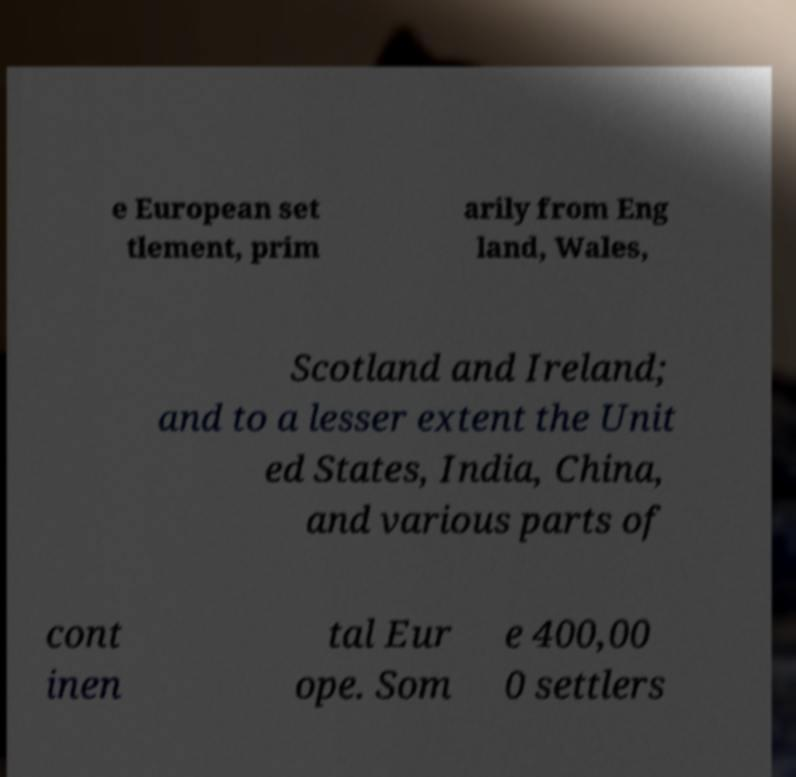What messages or text are displayed in this image? I need them in a readable, typed format. e European set tlement, prim arily from Eng land, Wales, Scotland and Ireland; and to a lesser extent the Unit ed States, India, China, and various parts of cont inen tal Eur ope. Som e 400,00 0 settlers 